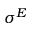Convert formula to latex. <formula><loc_0><loc_0><loc_500><loc_500>\sigma ^ { E }</formula> 